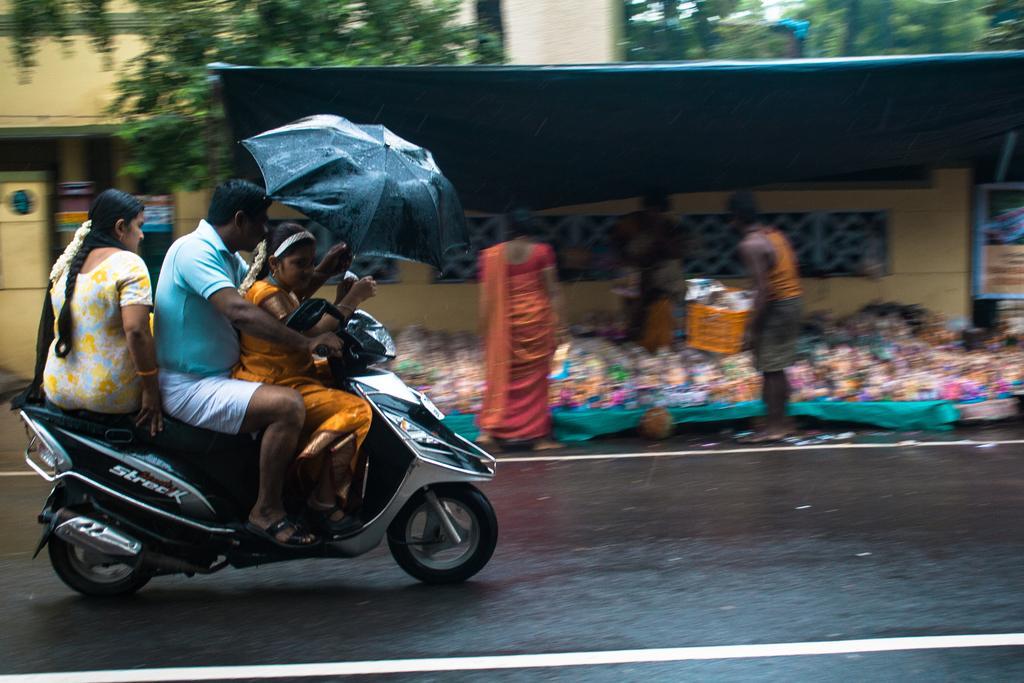Describe this image in one or two sentences. On the background we can see trees and a building. Here we can see three persons sitting on a bike and travelling on the road. This is a black umbrella. Here we can see a black cover shelter and idols on the other cover. We can see three persons standing near to these idols. 